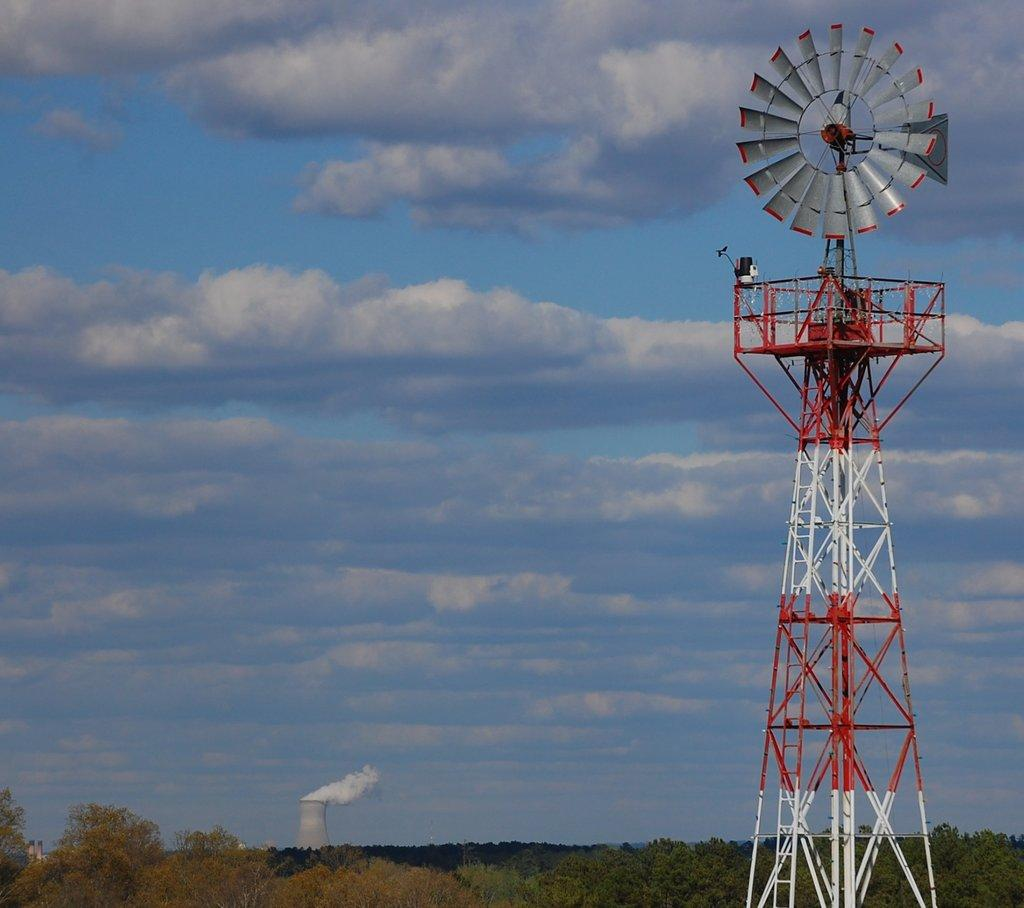What is the color of the sky in the image? The sky in the image is clear and blue. Are there any additional features in the sky besides its color? Yes, there are clouds visible in the sky. What type of vegetation can be seen in the image? There are trees in the image. What might be causing the smoke in the image? The source of the smoke is not visible in the image, so it cannot be determined. What type of structure is present in the image? There is a transmission tower in the image. Can you tell me how many marbles are rolling on the ground in the image? There are no marbles present in the image. What type of worm can be seen crawling on the transmission tower in the image? There are no worms present in the image, and the transmission tower is not a suitable habitat for worms. 